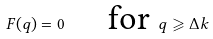Convert formula to latex. <formula><loc_0><loc_0><loc_500><loc_500>F ( q ) = 0 \text { \quad for } q \geqslant \Delta k</formula> 